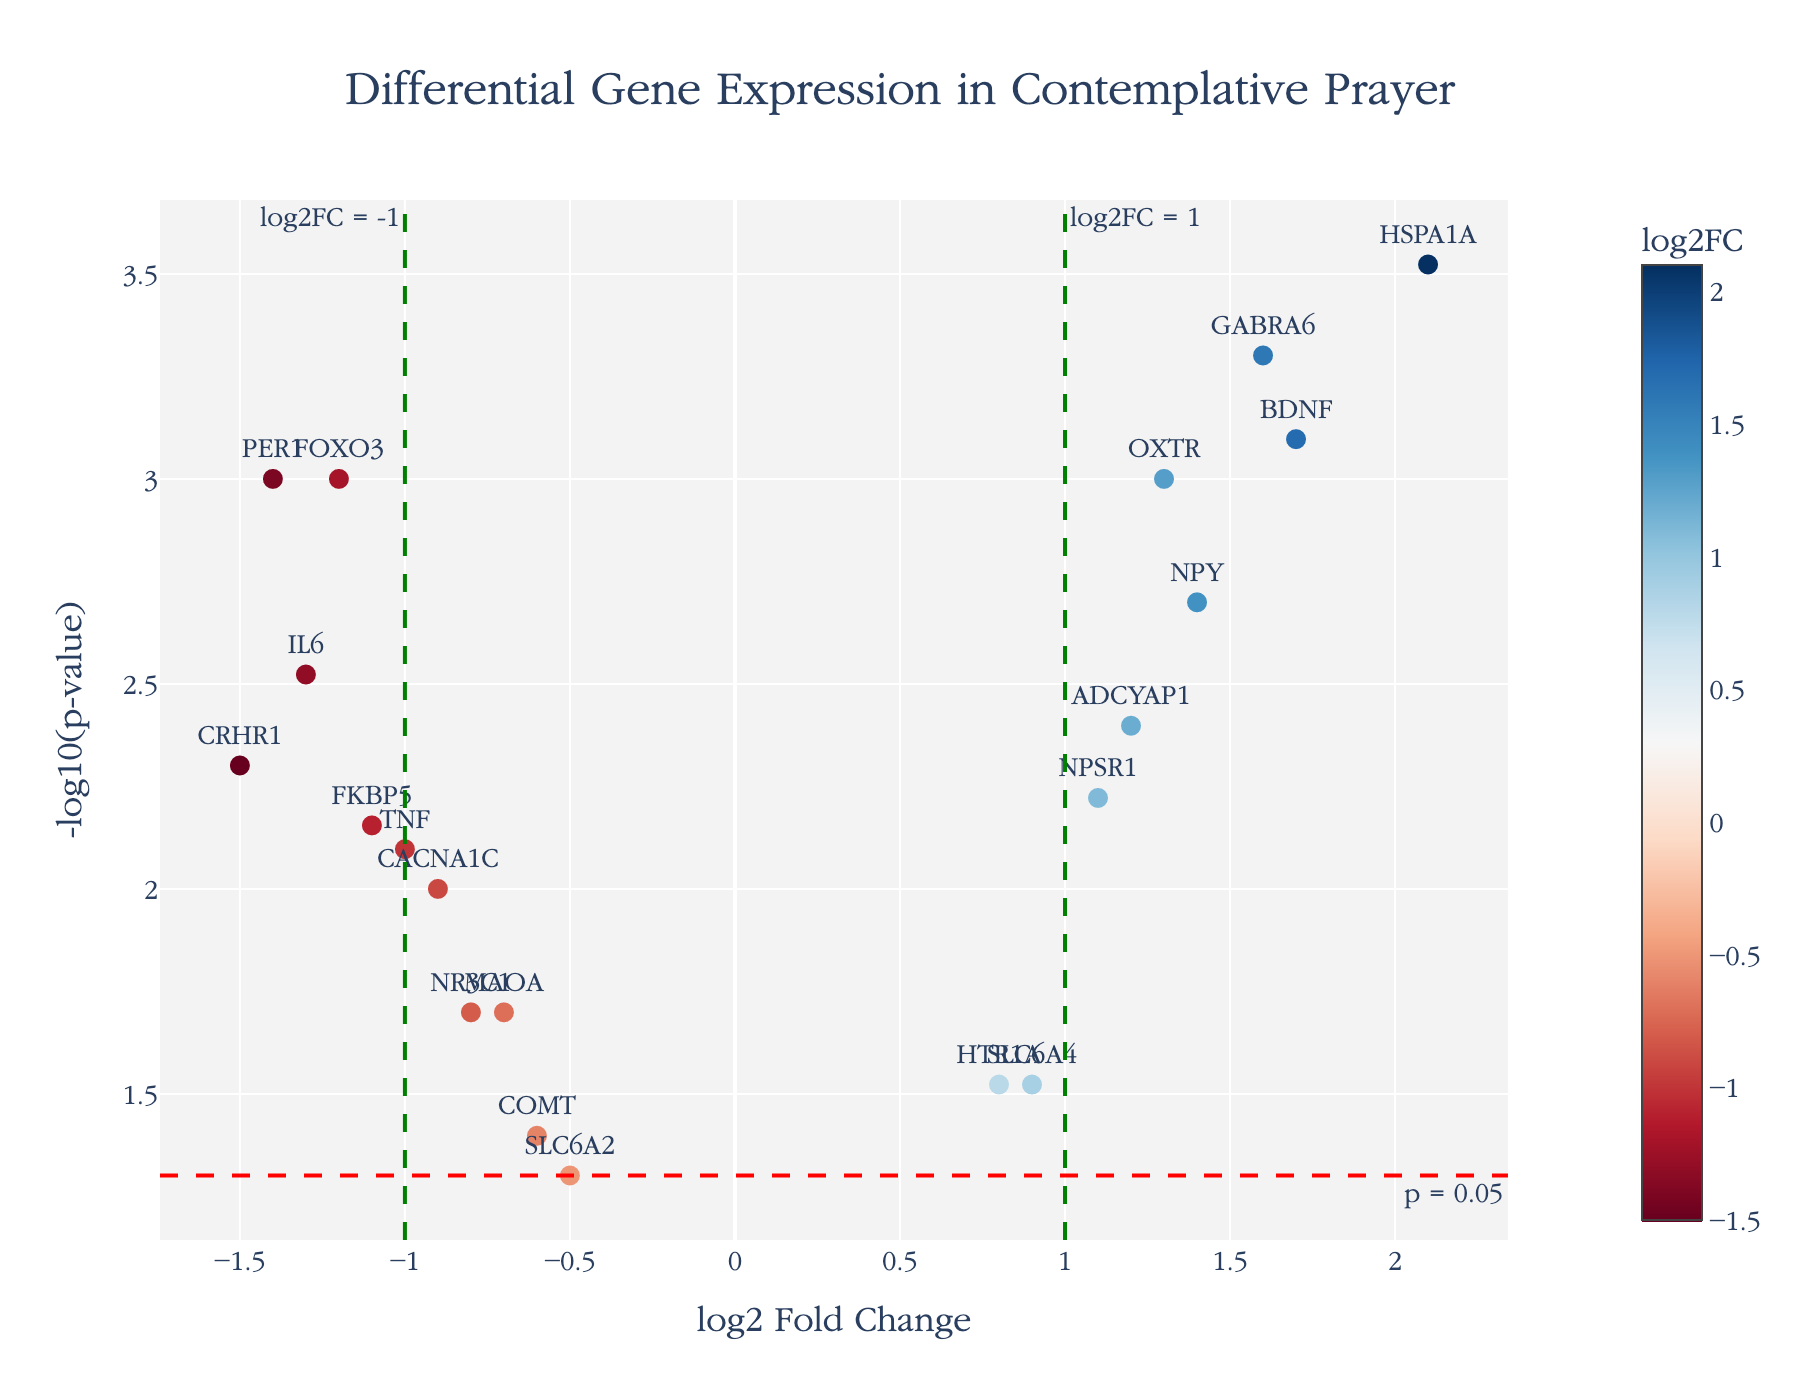What is the title of the figure? The title of the figure is prominently displayed at the top of the plot.
Answer: Differential Gene Expression in Contemplative Prayer How many genes have a p-value lower than 0.05? To determine this, look for genes with -log10(p-value) higher than -log10(0.05), which is approximately 1.3. Count these data points.
Answer: 17 Which gene has the highest log2 fold change, and what is its p-value? Locate the point farthest to the right on the x-axis, and check its p-value using the hover text or labels.
Answer: HSPA1A, 0.0003 How many genes have a log2 fold change greater than 1 and a p-value less than 0.05? Count the number of data points positioned to the right of log2FC = 1 line and above the horizontal threshold line indicating p=0.05. This requires identifying points with x > 1 and -log10(p-value) > 1.3.
Answer: 5 Which gene has the lowest -log10(p-value) and what is its log2 fold change? Find the data point with the smallest value on the y-axis and observe the associated log2 fold change. You can use hover text or labels to get this information.
Answer: SLC6A2, -0.5 Are there more genes with increased expression or decreased expression based on log2 fold change? Compare the number of data points on the right of the vertical line at log2FC = 0 (increased expression) with those on the left (decreased expression).
Answer: Increased expression Which genes have both a statistically significant p-value (less than 0.05) and a log2 fold change less than -1? Identify genes that are positioned to the left of log2FC = -1 line and above the horizontal threshold line indicating statistical significance.
Answer: CRHR1, FKBP5, PER1 What does the red horizontal line represent in the figure? The horizontal red dashed line represents the threshold of p = 0.05, depicted as -log10(0.05) on the y-axis.
Answer: Threshold for p = 0.05 How many genes are down-regulated (log2 fold change less than 0) and are statistically significant? Look for data points to the left of the log2FC = 0 vertical line and above the red horizontal line (indicating statistical significance). Count these points.
Answer: 9 What gene is positioned closest to the intersection of log2FC = 1 and the p-value threshold line? Identify the point where the green vertical dash line (log2FC = 1) intersects with the red horizontal dash line (p-value threshold) and determine the closest data point.
Answer: NPSR1 